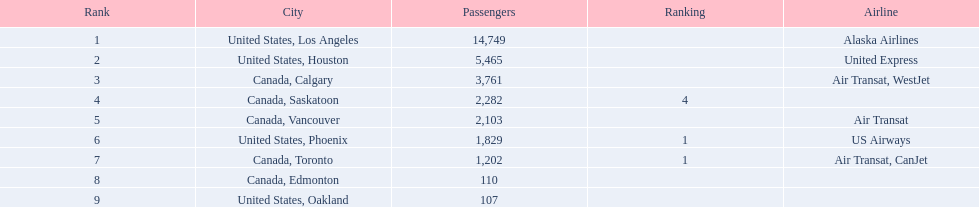Was los angeles or houston the busiest international route at manzanillo international airport in 2013? Los Angeles. 